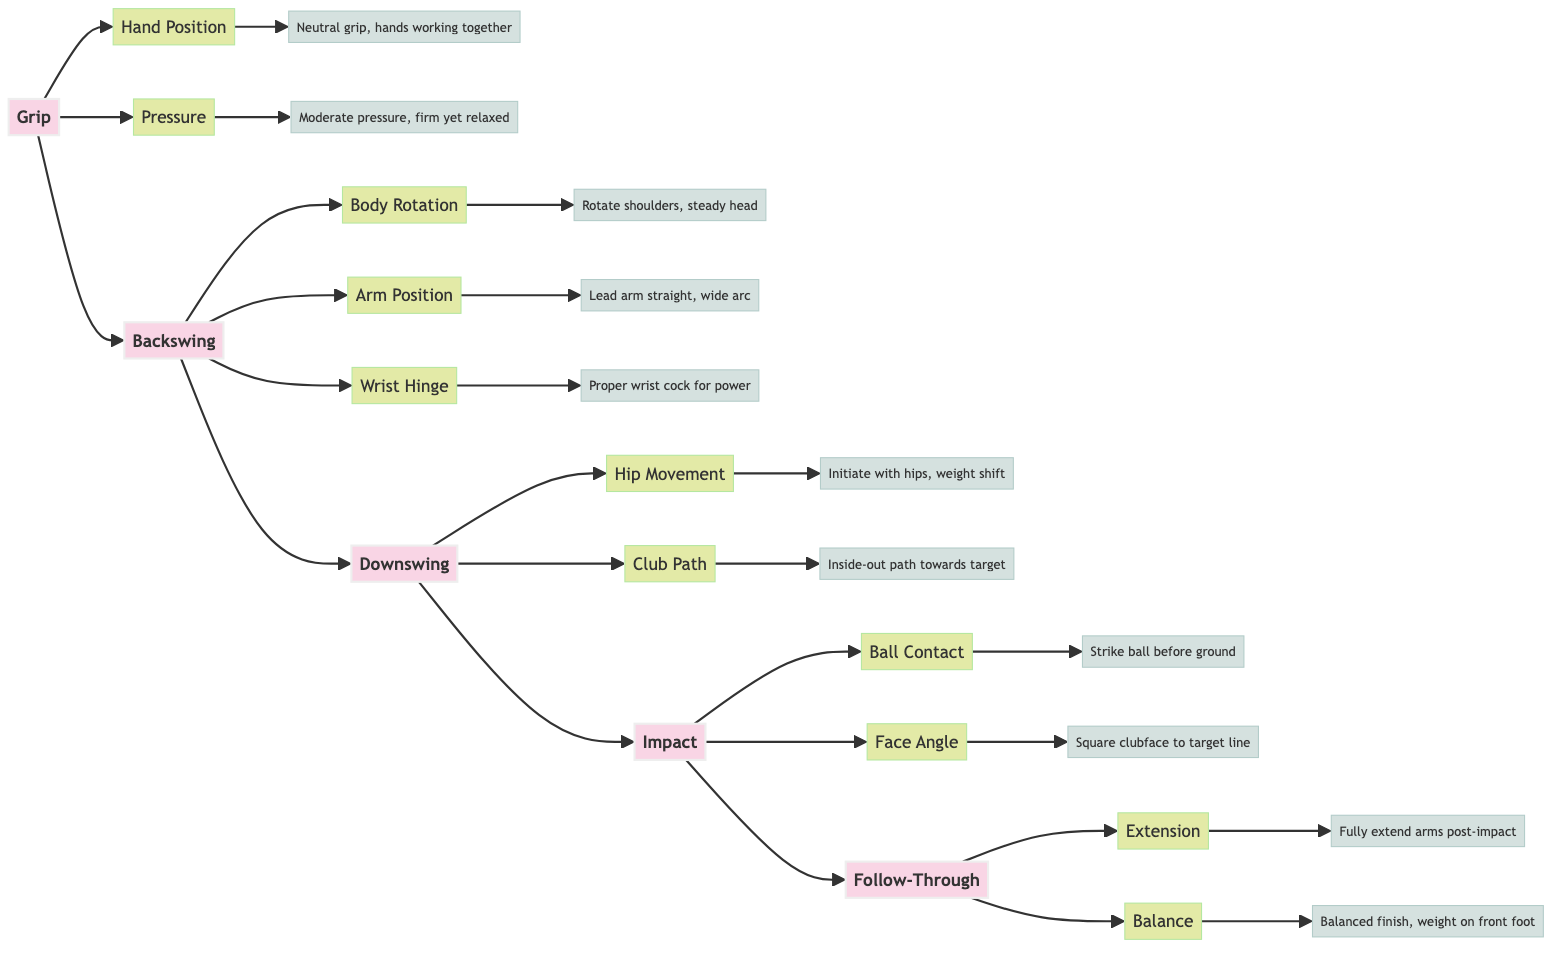What are the key points in the Grip phase? The diagram indicates that there are two key points in the Grip phase: Hand Position and Pressure.
Answer: Hand Position, Pressure How many key points are listed under Backswing? The diagram shows three key points for the Backswing phase: Body Rotation, Arm Position, and Wrist Hinge.
Answer: 3 Which phase follows the Downswing? Following the Downswing phase in the diagram is the Impact phase, indicating the flow of the golf swing.
Answer: Impact What is the detail associated with "Ball Contact"? The detail associated with Ball Contact is "Strike the ball before the ground," which emphasizes the importance of timing in the impact phase.
Answer: Strike the ball before the ground What initiates the downswing according to the diagram? The diagram states that hip movement initiates the downswing, highlighting the importance of proper weight shift in this phase.
Answer: Hip Movement What is the last key point in the Follow-Through phase? The last key point in the Follow-Through phase is Balance, which refers to finishing in a controlled position after the swing.
Answer: Balance What is the relationship between the Backswing and Downswing phases? The diagram illustrates that the Backswing phase leads directly into the Downswing phase, indicating the sequence of the swing.
Answer: Backswing leads to Downswing How many phases are included in the Golf Swing Analysis? The diagram outlines five phases in the Golf Swing Analysis: Grip, Backswing, Downswing, Impact, and Follow-Through.
Answer: 5 What should be ensured regarding the clubface at Impact? It is indicated that the clubface should be square to the target line at Impact, which helps optimize direction and launch conditions.
Answer: Square clubface to target line 